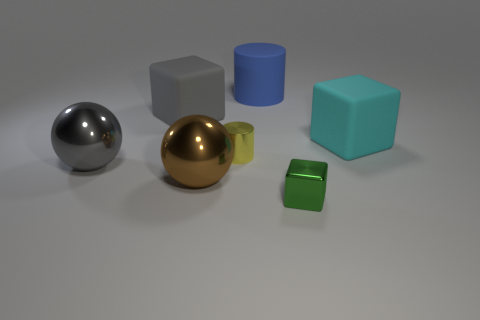What can you infer about the setting of this image? This image seems to be a composition likely created for a visual study or a graphics demonstration. The collection of geometric shapes and varying materials suggests an artificial arrangement, possibly rendered using 3D modeling software, displaying how different textures and colors interact with a common light source. 